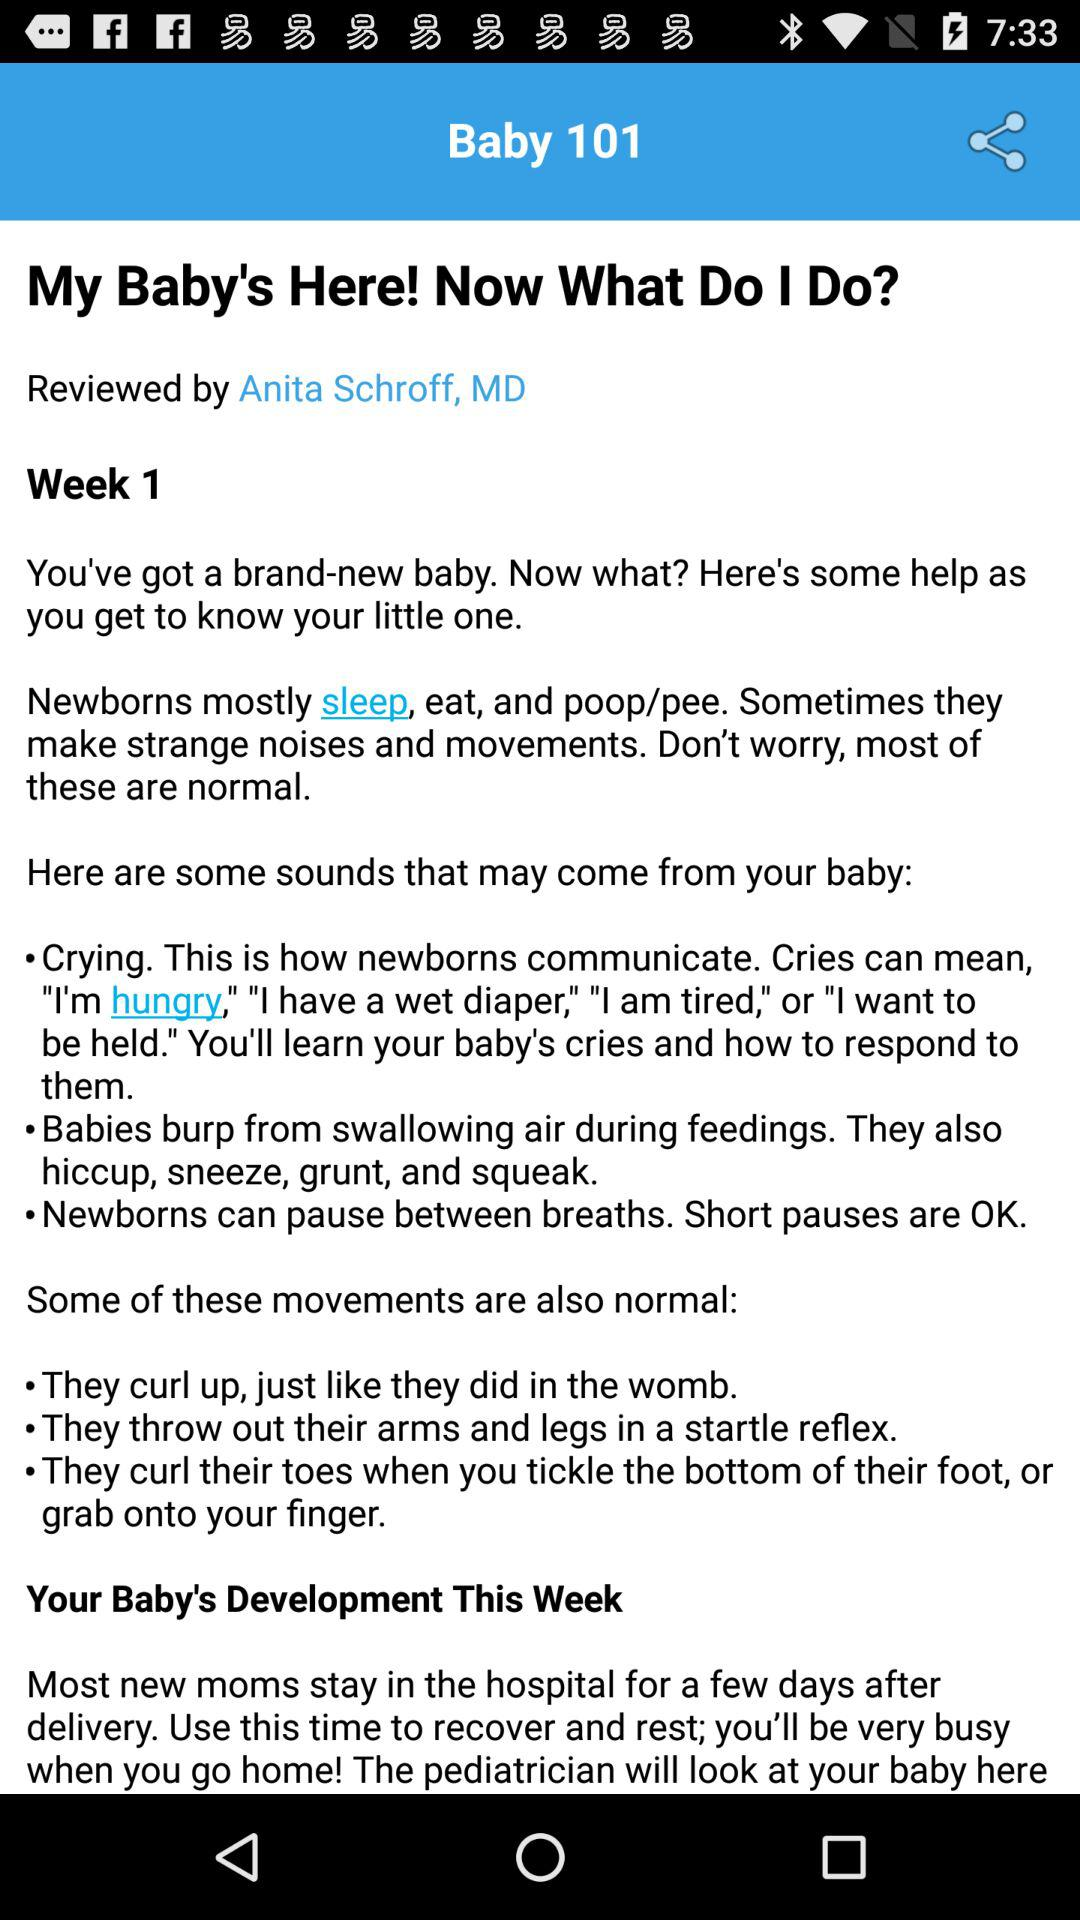Through which applications can this information be shared?
When the provided information is insufficient, respond with <no answer>. <no answer> 